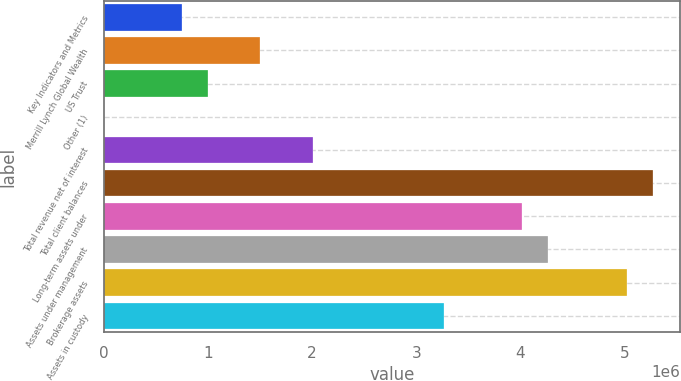<chart> <loc_0><loc_0><loc_500><loc_500><bar_chart><fcel>Key Indicators and Metrics<fcel>Merrill Lynch Global Wealth<fcel>US Trust<fcel>Other (1)<fcel>Total revenue net of interest<fcel>Total client balances<fcel>Long-term assets under<fcel>Assets under management<fcel>Brokerage assets<fcel>Assets in custody<nl><fcel>752632<fcel>1.50518e+06<fcel>1.00348e+06<fcel>89<fcel>2.00687e+06<fcel>5.26789e+06<fcel>4.01365e+06<fcel>4.2645e+06<fcel>5.01704e+06<fcel>3.26111e+06<nl></chart> 